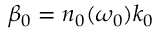Convert formula to latex. <formula><loc_0><loc_0><loc_500><loc_500>\beta _ { 0 } = n _ { 0 } ( \omega _ { 0 } ) k _ { 0 }</formula> 